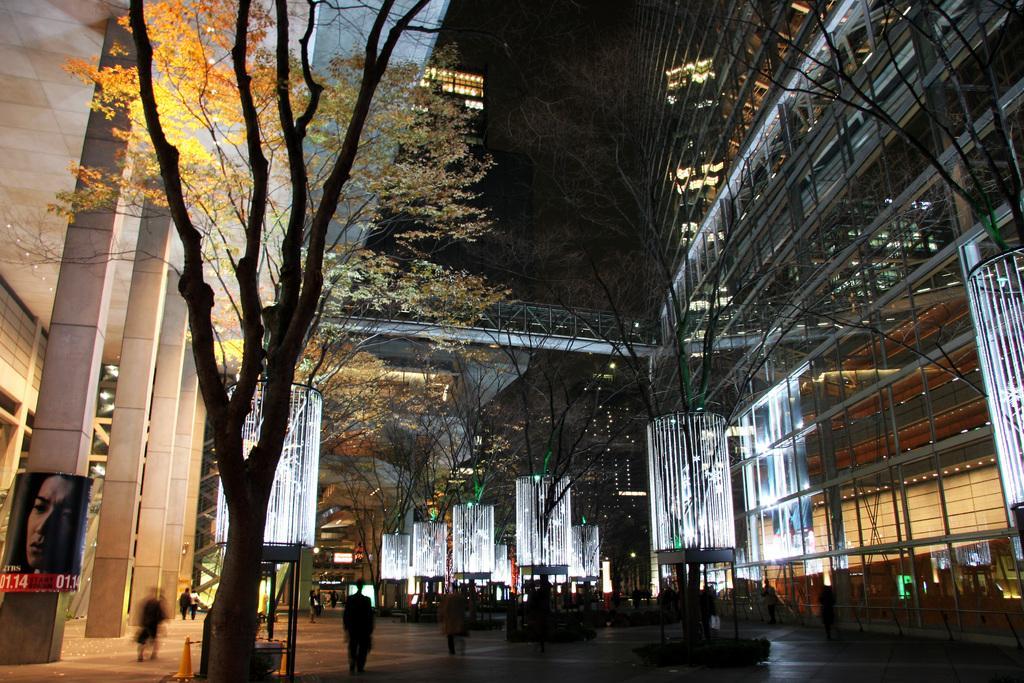Can you describe this image briefly? This image on the left side, we see a tree and on the bottom left hand corner there is poster on the pillar. 